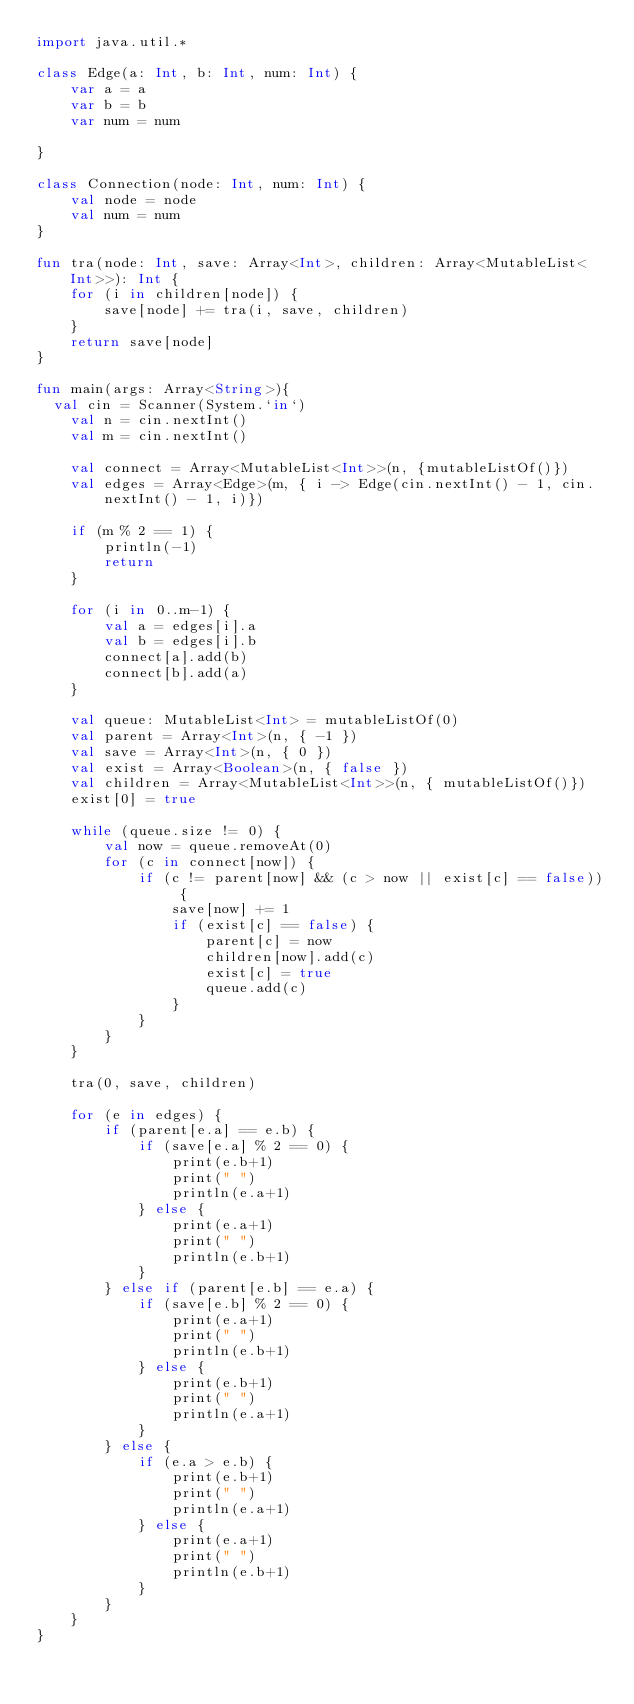<code> <loc_0><loc_0><loc_500><loc_500><_Kotlin_>import java.util.*

class Edge(a: Int, b: Int, num: Int) {
    var a = a
    var b = b
    var num = num

}

class Connection(node: Int, num: Int) {
    val node = node
    val num = num
}

fun tra(node: Int, save: Array<Int>, children: Array<MutableList<Int>>): Int {
    for (i in children[node]) {
        save[node] += tra(i, save, children)
    }
    return save[node]
}

fun main(args: Array<String>){
	val cin = Scanner(System.`in`)
    val n = cin.nextInt()
    val m = cin.nextInt()

    val connect = Array<MutableList<Int>>(n, {mutableListOf()})
    val edges = Array<Edge>(m, { i -> Edge(cin.nextInt() - 1, cin.nextInt() - 1, i)})

    if (m % 2 == 1) {
        println(-1)
        return
    }

    for (i in 0..m-1) {
        val a = edges[i].a
        val b = edges[i].b
        connect[a].add(b)
        connect[b].add(a)
    }

    val queue: MutableList<Int> = mutableListOf(0)
    val parent = Array<Int>(n, { -1 })
    val save = Array<Int>(n, { 0 })
    val exist = Array<Boolean>(n, { false })
    val children = Array<MutableList<Int>>(n, { mutableListOf()})
    exist[0] = true

    while (queue.size != 0) {
        val now = queue.removeAt(0)
        for (c in connect[now]) {
            if (c != parent[now] && (c > now || exist[c] == false)) {
                save[now] += 1
                if (exist[c] == false) {
                    parent[c] = now
                    children[now].add(c)
                    exist[c] = true
                    queue.add(c)
                }
            }
        }
    }

    tra(0, save, children)

    for (e in edges) {
        if (parent[e.a] == e.b) {
            if (save[e.a] % 2 == 0) {
                print(e.b+1)
                print(" ")
                println(e.a+1)
            } else {
                print(e.a+1)
                print(" ")
                println(e.b+1)
            }
        } else if (parent[e.b] == e.a) {
            if (save[e.b] % 2 == 0) {
                print(e.a+1)
                print(" ")
                println(e.b+1)
            } else {
                print(e.b+1)
                print(" ")
                println(e.a+1)
            }
        } else {
            if (e.a > e.b) {
                print(e.b+1)
                print(" ")
                println(e.a+1)
            } else {
                print(e.a+1)
                print(" ")
                println(e.b+1)
            }
        }
    }
}</code> 